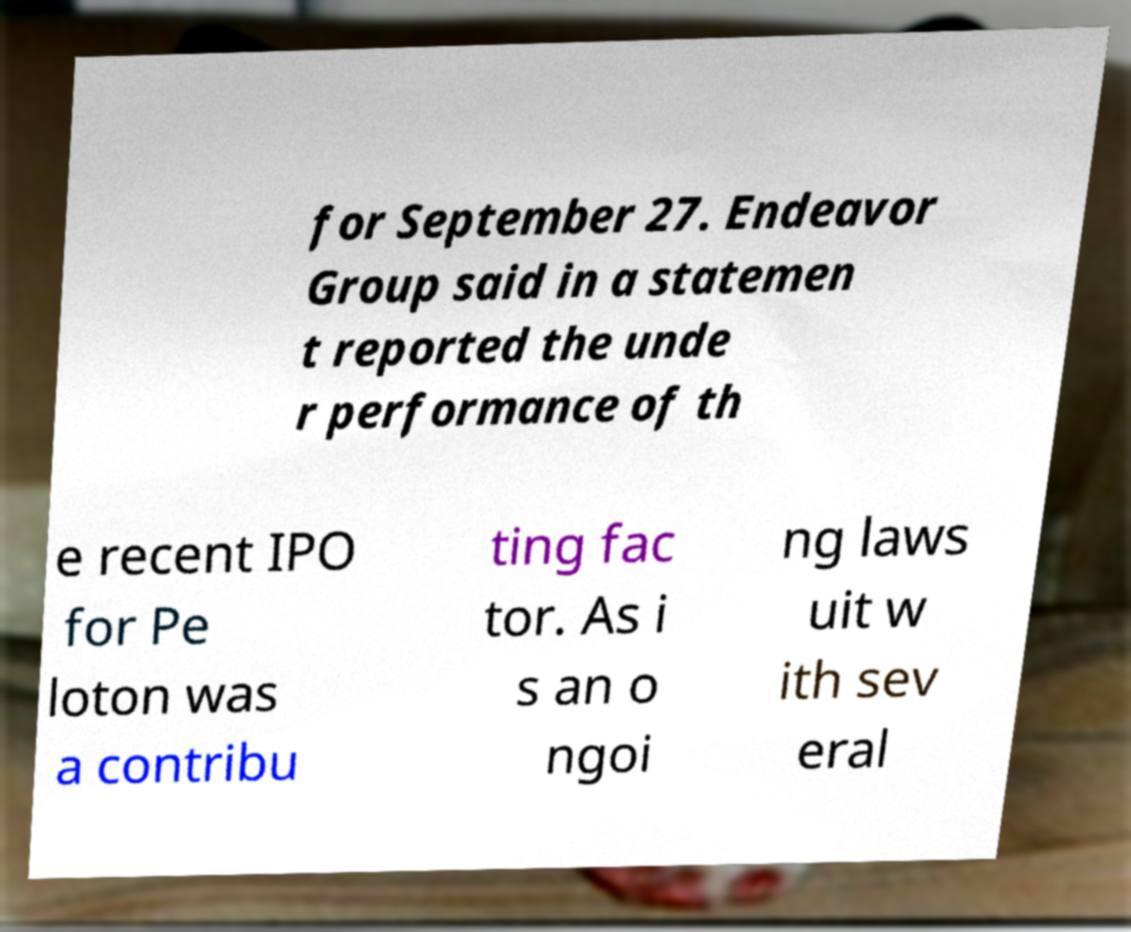Can you read and provide the text displayed in the image?This photo seems to have some interesting text. Can you extract and type it out for me? for September 27. Endeavor Group said in a statemen t reported the unde r performance of th e recent IPO for Pe loton was a contribu ting fac tor. As i s an o ngoi ng laws uit w ith sev eral 